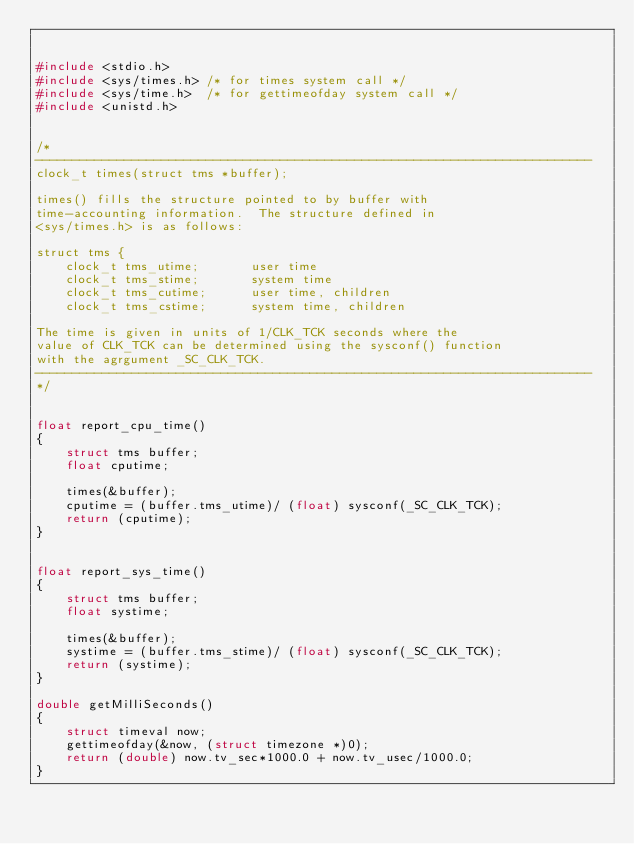Convert code to text. <code><loc_0><loc_0><loc_500><loc_500><_C_>

#include <stdio.h>
#include <sys/times.h> /* for times system call */
#include <sys/time.h>  /* for gettimeofday system call */
#include <unistd.h>


/*
---------------------------------------------------------------------------
clock_t times(struct tms *buffer);

times() fills the structure pointed to by buffer with
time-accounting information.  The structure defined in
<sys/times.h> is as follows:

struct tms {
    clock_t tms_utime;       user time
    clock_t tms_stime;       system time
    clock_t tms_cutime;      user time, children
    clock_t tms_cstime;      system time, children

The time is given in units of 1/CLK_TCK seconds where the
value of CLK_TCK can be determined using the sysconf() function
with the agrgument _SC_CLK_TCK.
---------------------------------------------------------------------------
*/


float report_cpu_time()
{
    struct tms buffer;
    float cputime;

    times(&buffer);
    cputime = (buffer.tms_utime)/ (float) sysconf(_SC_CLK_TCK);
    return (cputime);
}


float report_sys_time()
{
    struct tms buffer;
    float systime;

    times(&buffer);
    systime = (buffer.tms_stime)/ (float) sysconf(_SC_CLK_TCK);
    return (systime);
}

double getMilliSeconds()
{
    struct timeval now;
    gettimeofday(&now, (struct timezone *)0);
    return (double) now.tv_sec*1000.0 + now.tv_usec/1000.0;
}

</code> 